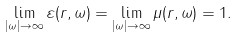<formula> <loc_0><loc_0><loc_500><loc_500>\lim _ { | \omega | \to \infty } \varepsilon ( { r } , \omega ) = \lim _ { | \omega | \to \infty } \mu ( { r } , \omega ) = 1 .</formula> 